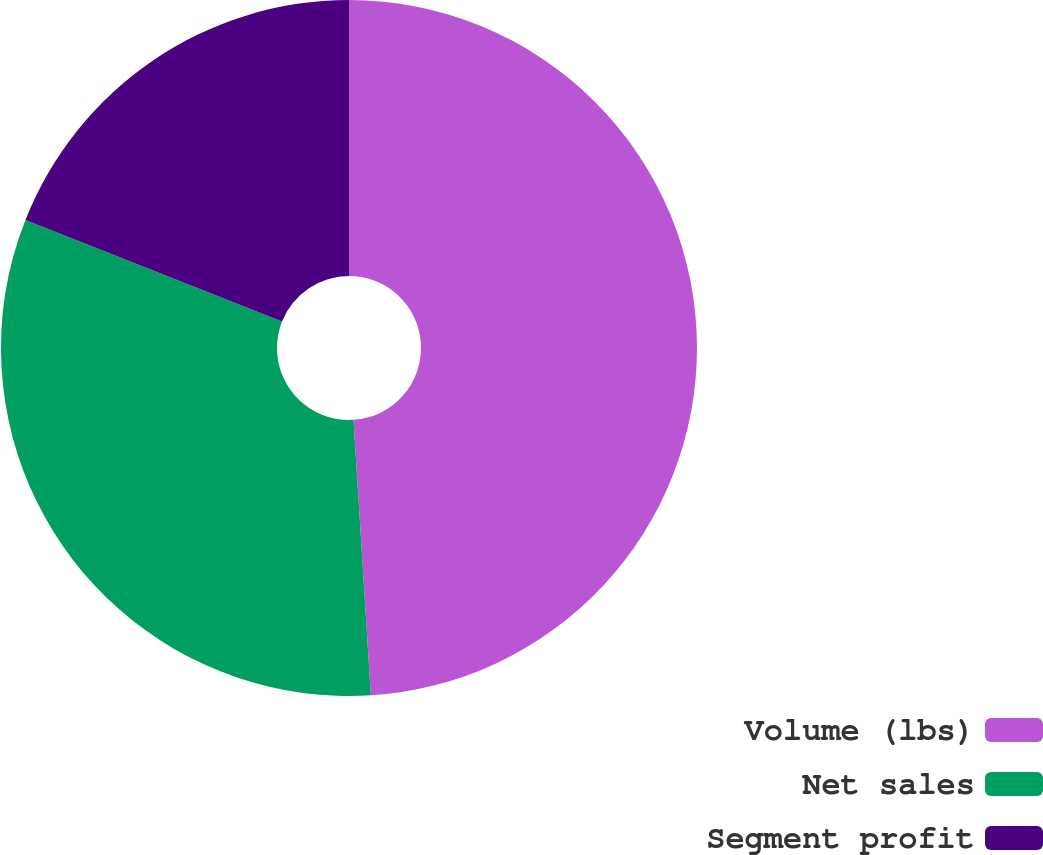Convert chart to OTSL. <chart><loc_0><loc_0><loc_500><loc_500><pie_chart><fcel>Volume (lbs)<fcel>Net sales<fcel>Segment profit<nl><fcel>49.0%<fcel>32.0%<fcel>19.0%<nl></chart> 